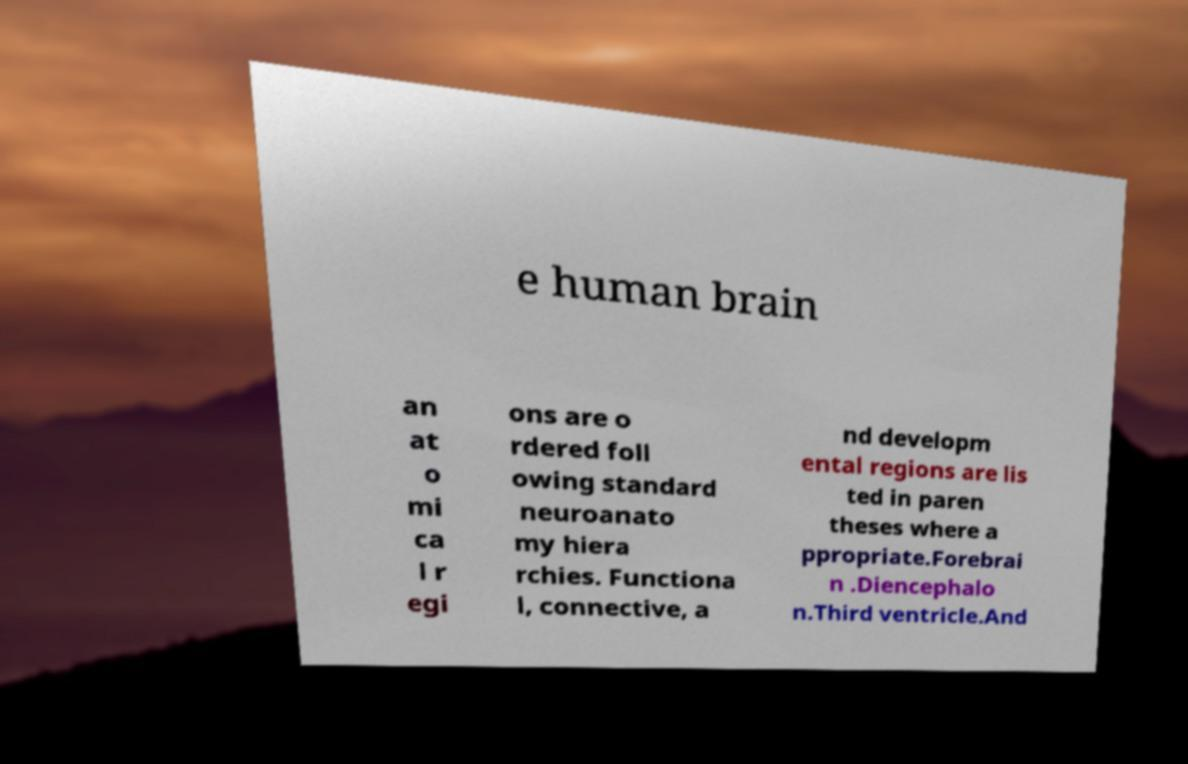What messages or text are displayed in this image? I need them in a readable, typed format. e human brain an at o mi ca l r egi ons are o rdered foll owing standard neuroanato my hiera rchies. Functiona l, connective, a nd developm ental regions are lis ted in paren theses where a ppropriate.Forebrai n .Diencephalo n.Third ventricle.And 